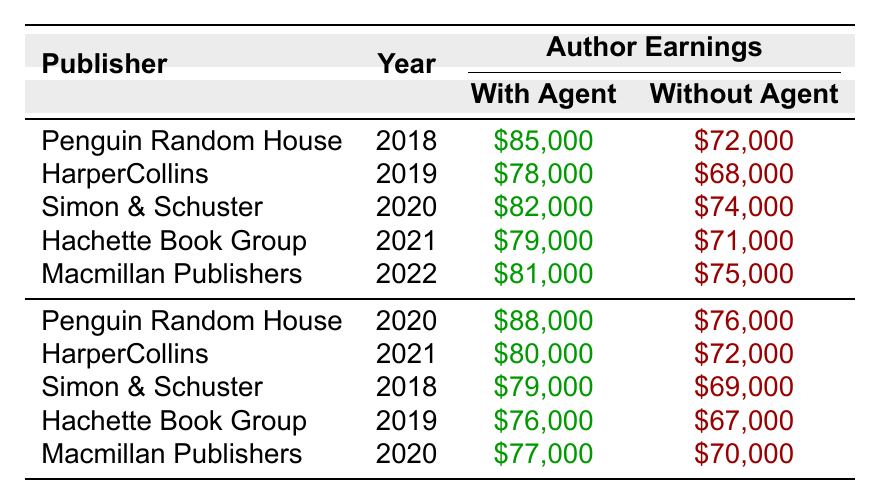What were the author earnings with the agent for Simon & Schuster in 2020? According to the table, the earnings with the agent for Simon & Schuster in 2020 is listed as $82,000.
Answer: $82,000 What were the author earnings without the agent for Macmillan Publishers in 2022? The table shows that the earnings without the agent for Macmillan Publishers in 2022 is $75,000.
Answer: $75,000 Which publisher had the highest earnings with agents in 2020? The highest earnings with agents in 2020 is $88,000 from Penguin Random House.
Answer: Penguin Random House What is the difference in author earnings with and without agents for HarperCollins in 2019? For HarperCollins in 2019, the earnings with agent is $78,000 and without agent is $68,000. The difference is $78,000 - $68,000 = $10,000.
Answer: $10,000 What are the author earnings without agents for Penguin Random House across all years listed? The earnings without agents are $72,000 (2018), $76,000 (2020). The average of these values is ($72,000 + $76,000) / 2 = $74,000.
Answer: $74,000 Is it true that author earnings without agents were always lower than those with agents for every publisher listed? Examining the data, in each case, the earnings without agents are less than the earnings with agents across all years for every publisher listed. Therefore, this statement is true.
Answer: Yes What was the average earning of authors with agents across all years and publishers? To find the average with agents, we sum all values: $85,000 + $78,000 + $82,000 + $79,000 + $81,000 + $88,000 + $80,000 + $79,000 + $76,000 + $77,000 = $800,000. There are 10 data points, so the average is $800,000 / 10 = $80,000.
Answer: $80,000 Which year had the lowest earning for authors without agents and what was that amount? Looking through the data, the lowest earnings without agents was $67,000 in 2019 for Hachette Book Group.
Answer: $67,000 What was the total earning difference with and without agents for all publishers across all years? To find the total difference, sum all 'with agent' values and all 'without agent' values separately. The total with agents is $800,000 and without agents is $727,000. The total difference is $800,000 - $727,000 = $73,000.
Answer: $73,000 Which publishing house showed the least difference between earnings with agents and without agents in 2021? For Hachette Book Group in 2021, the earnings with agent ($79,000) and without agent ($71,000) gives a difference of $8,000, which is less than other publishers' differences in that year.
Answer: Hachette Book Group 